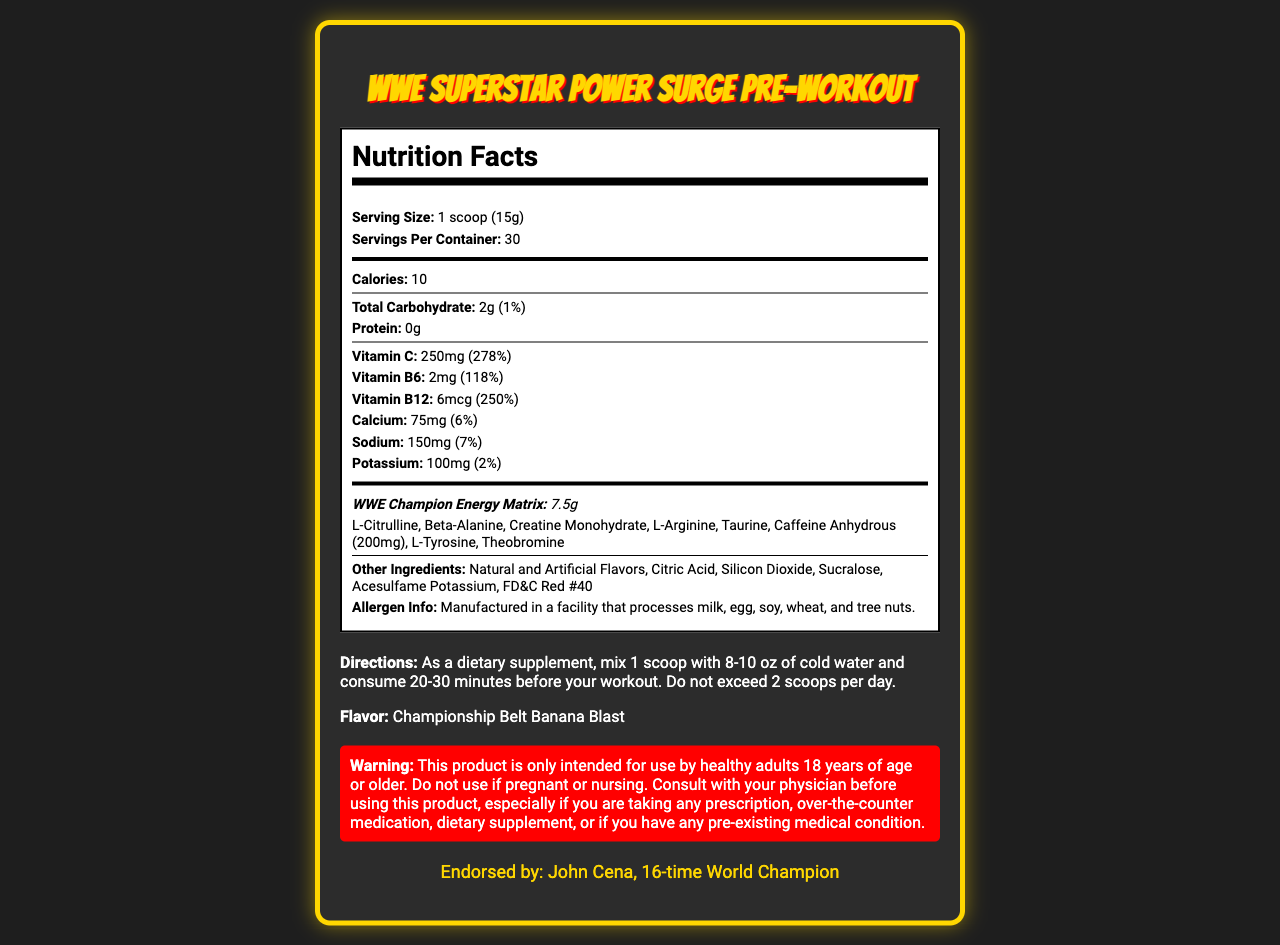who endorses the product? The document mentions that the product is endorsed by John Cena, 16-time World Champion.
Answer: John Cena what is the flavor of the pre-workout supplement? The document lists "Championship Belt Banana Blast" as the flavor.
Answer: Championship Belt Banana Blast how many calories does one serving contain? According to the document, one serving contains 10 calories.
Answer: 10 how much vitamin C is in one serving, and what percentage of the daily value does it represent? One serving of the pre-workout supplement contains 250 mg of vitamin C, which represents 278% of the daily value.
Answer: 250mg, 278% how many servings are in each container? The document specifies that there are 30 servings per container.
Answer: 30 what is the serving size for the product? The serving size is listed as 1 scoop, which equals 15 grams.
Answer: 1 scoop (15g) what is the main idea of the document? It summarizes the product information and nutritional details, highlighting key features and endorsements.
Answer: The document provides the nutritional facts and usage instructions for the "WWE Superstar Power Surge Pre-Workout" supplement, including its ingredients, endorsed by John Cena, and offering a Championship Belt Banana Blast flavor. can you consume more than 2 scoops per day of this product? The document specifies a warning that you should not exceed 2 scoops per day.
Answer: No which vitamin has the highest daily value percentage, and what is that percentage?
A. Vitamin C
B. Vitamin B6
C. Vitamin B12 Vitamin C has the highest daily value percentage at 278%.
Answer: A what is the proprietary blend called? The proprietary blend is named "WWE Champion Energy Matrix".
Answer: WWE Champion Energy Matrix which of the following ingredients is not part of the proprietary blend?
A. L-Citrulline
B. Beta-Alanine
C. Creatine Monohydrate
D. Silicon Dioxide Silicon Dioxide is listed under "Other Ingredients," not part of the proprietary blend.
Answer: D does this product contain any protein? The document states that the product contains 0g of protein.
Answer: No what should you do if you are pregnant or nursing? The warning section advises consulting with a physician if you are pregnant or nursing.
Answer: Consult with your physician before using this product. how much sodium is in one serving, and what percentage of the daily value does it represent? One serving contains 150 mg of sodium, which is 7% of the daily value.
Answer: 150mg, 7% is taurin one of the ingredients in the proprietary blend? Taurine is listed as one of the ingredients in the WWE Champion Energy Matrix proprietary blend.
Answer: Yes which ingredient provides caffeine in the blend? Caffeine Anhydrous is the ingredient that provides caffeine, with 200 mg per serving.
Answer: Caffeine Anhydrous (200mg) list all the major vitamins included in this supplement and their respective daily values. The major vitamins included are Vitamin C (278%), Vitamin B6 (118%), and Vitamin B12 (250%).
Answer: Vitamin C (278%), Vitamin B6 (118%), Vitamin B12 (250%) how should the supplement be consumed? The directions specify mixing 1 scoop with 8-10 oz of cold water and consuming it 20-30 minutes before a workout, with a limit of 2 scoops per day.
Answer: Mix 1 scoop with 8-10 oz of cold water and consume 20-30 minutes before your workout. Do not exceed 2 scoops per day. how much potassium is in one serving, and what percentage of the daily value does it represent? One serving contains 100 mg of potassium, which is 2% of the daily value.
Answer: 100mg, 2% how much creatine monohydrate is in the proprietary blend? The total amount of the proprietary blend is listed, but individual quantities of ingredients like creatine monohydrate are not specified.
Answer: Not specified does the product contain any allergen information? The document specifies that the product is manufactured in a facility that processes milk, egg, soy, wheat, and tree nuts.
Answer: Yes 